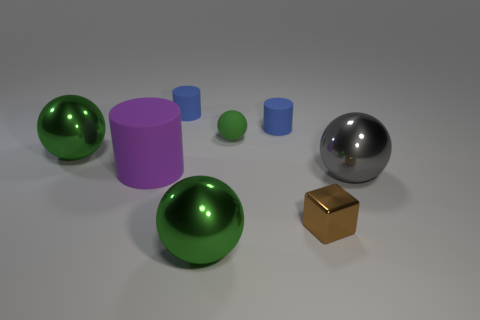What material is the big gray thing in front of the green metal sphere that is behind the tiny metallic cube?
Provide a short and direct response. Metal. There is a purple rubber cylinder; does it have the same size as the metal ball that is to the left of the purple thing?
Provide a succinct answer. Yes. Is there a small cube that has the same color as the big cylinder?
Offer a terse response. No. How many big things are either blue matte cylinders or blue balls?
Provide a succinct answer. 0. What number of yellow metal cylinders are there?
Your answer should be compact. 0. What is the green object to the left of the purple rubber thing made of?
Your answer should be compact. Metal. There is a big purple rubber thing; are there any small cylinders in front of it?
Make the answer very short. No. Do the purple cylinder and the brown metallic thing have the same size?
Provide a short and direct response. No. How many brown objects are made of the same material as the large gray thing?
Keep it short and to the point. 1. There is a green metal object behind the green shiny thing in front of the brown object; what is its size?
Make the answer very short. Large. 